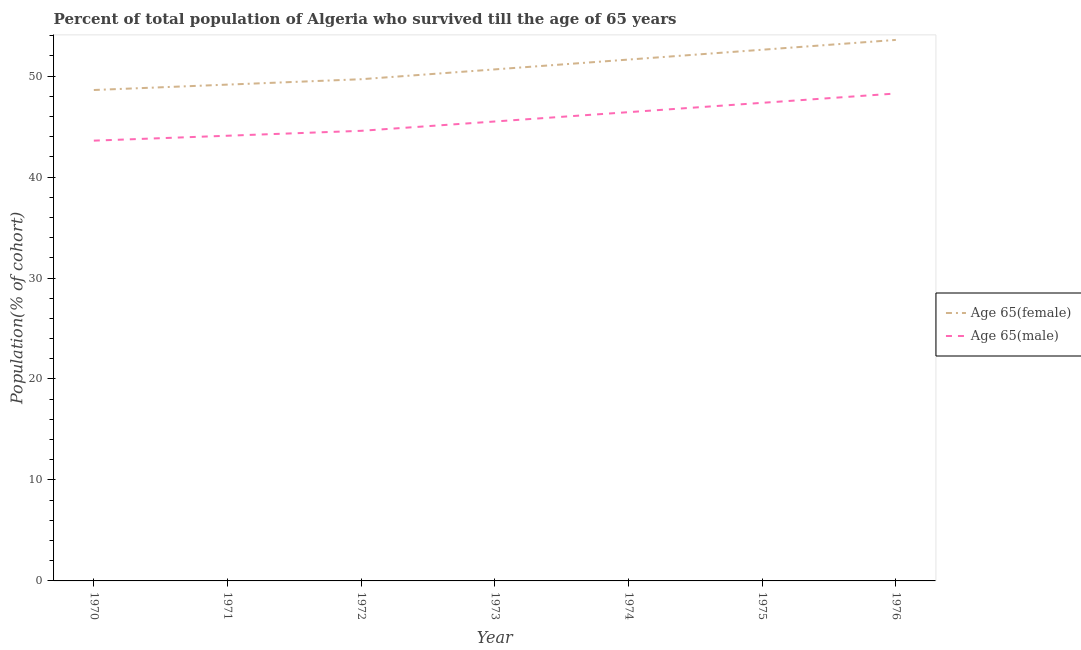Does the line corresponding to percentage of male population who survived till age of 65 intersect with the line corresponding to percentage of female population who survived till age of 65?
Ensure brevity in your answer.  No. Is the number of lines equal to the number of legend labels?
Keep it short and to the point. Yes. What is the percentage of female population who survived till age of 65 in 1976?
Offer a very short reply. 53.58. Across all years, what is the maximum percentage of male population who survived till age of 65?
Your answer should be very brief. 48.27. Across all years, what is the minimum percentage of male population who survived till age of 65?
Ensure brevity in your answer.  43.6. In which year was the percentage of male population who survived till age of 65 maximum?
Make the answer very short. 1976. In which year was the percentage of male population who survived till age of 65 minimum?
Make the answer very short. 1970. What is the total percentage of female population who survived till age of 65 in the graph?
Your response must be concise. 355.94. What is the difference between the percentage of male population who survived till age of 65 in 1970 and that in 1973?
Your answer should be compact. -1.9. What is the difference between the percentage of female population who survived till age of 65 in 1972 and the percentage of male population who survived till age of 65 in 1970?
Give a very brief answer. 6.08. What is the average percentage of male population who survived till age of 65 per year?
Your response must be concise. 45.69. In the year 1975, what is the difference between the percentage of male population who survived till age of 65 and percentage of female population who survived till age of 65?
Provide a short and direct response. -5.26. What is the ratio of the percentage of female population who survived till age of 65 in 1974 to that in 1976?
Keep it short and to the point. 0.96. Is the percentage of female population who survived till age of 65 in 1973 less than that in 1976?
Ensure brevity in your answer.  Yes. What is the difference between the highest and the second highest percentage of male population who survived till age of 65?
Your answer should be very brief. 0.92. What is the difference between the highest and the lowest percentage of male population who survived till age of 65?
Your answer should be very brief. 4.67. In how many years, is the percentage of male population who survived till age of 65 greater than the average percentage of male population who survived till age of 65 taken over all years?
Your response must be concise. 3. Is the sum of the percentage of male population who survived till age of 65 in 1975 and 1976 greater than the maximum percentage of female population who survived till age of 65 across all years?
Offer a terse response. Yes. Does the percentage of male population who survived till age of 65 monotonically increase over the years?
Your response must be concise. Yes. How many lines are there?
Give a very brief answer. 2. What is the difference between two consecutive major ticks on the Y-axis?
Ensure brevity in your answer.  10. Are the values on the major ticks of Y-axis written in scientific E-notation?
Provide a short and direct response. No. How many legend labels are there?
Your answer should be compact. 2. What is the title of the graph?
Your response must be concise. Percent of total population of Algeria who survived till the age of 65 years. Does "Number of arrivals" appear as one of the legend labels in the graph?
Provide a succinct answer. No. What is the label or title of the Y-axis?
Offer a terse response. Population(% of cohort). What is the Population(% of cohort) of Age 65(female) in 1970?
Make the answer very short. 48.62. What is the Population(% of cohort) of Age 65(male) in 1970?
Keep it short and to the point. 43.6. What is the Population(% of cohort) in Age 65(female) in 1971?
Ensure brevity in your answer.  49.15. What is the Population(% of cohort) in Age 65(male) in 1971?
Make the answer very short. 44.09. What is the Population(% of cohort) of Age 65(female) in 1972?
Make the answer very short. 49.69. What is the Population(% of cohort) in Age 65(male) in 1972?
Keep it short and to the point. 44.58. What is the Population(% of cohort) of Age 65(female) in 1973?
Make the answer very short. 50.66. What is the Population(% of cohort) of Age 65(male) in 1973?
Your response must be concise. 45.5. What is the Population(% of cohort) of Age 65(female) in 1974?
Your answer should be very brief. 51.63. What is the Population(% of cohort) in Age 65(male) in 1974?
Provide a succinct answer. 46.42. What is the Population(% of cohort) of Age 65(female) in 1975?
Provide a short and direct response. 52.61. What is the Population(% of cohort) of Age 65(male) in 1975?
Your answer should be very brief. 47.35. What is the Population(% of cohort) of Age 65(female) in 1976?
Offer a very short reply. 53.58. What is the Population(% of cohort) in Age 65(male) in 1976?
Provide a succinct answer. 48.27. Across all years, what is the maximum Population(% of cohort) of Age 65(female)?
Offer a very short reply. 53.58. Across all years, what is the maximum Population(% of cohort) of Age 65(male)?
Your response must be concise. 48.27. Across all years, what is the minimum Population(% of cohort) of Age 65(female)?
Give a very brief answer. 48.62. Across all years, what is the minimum Population(% of cohort) in Age 65(male)?
Your answer should be compact. 43.6. What is the total Population(% of cohort) of Age 65(female) in the graph?
Your response must be concise. 355.94. What is the total Population(% of cohort) in Age 65(male) in the graph?
Provide a succinct answer. 319.82. What is the difference between the Population(% of cohort) of Age 65(female) in 1970 and that in 1971?
Keep it short and to the point. -0.53. What is the difference between the Population(% of cohort) in Age 65(male) in 1970 and that in 1971?
Give a very brief answer. -0.49. What is the difference between the Population(% of cohort) in Age 65(female) in 1970 and that in 1972?
Make the answer very short. -1.07. What is the difference between the Population(% of cohort) in Age 65(male) in 1970 and that in 1972?
Your answer should be compact. -0.97. What is the difference between the Population(% of cohort) in Age 65(female) in 1970 and that in 1973?
Make the answer very short. -2.04. What is the difference between the Population(% of cohort) of Age 65(male) in 1970 and that in 1973?
Offer a very short reply. -1.9. What is the difference between the Population(% of cohort) in Age 65(female) in 1970 and that in 1974?
Offer a very short reply. -3.02. What is the difference between the Population(% of cohort) of Age 65(male) in 1970 and that in 1974?
Your answer should be compact. -2.82. What is the difference between the Population(% of cohort) in Age 65(female) in 1970 and that in 1975?
Your answer should be very brief. -3.99. What is the difference between the Population(% of cohort) in Age 65(male) in 1970 and that in 1975?
Your answer should be very brief. -3.75. What is the difference between the Population(% of cohort) in Age 65(female) in 1970 and that in 1976?
Ensure brevity in your answer.  -4.96. What is the difference between the Population(% of cohort) in Age 65(male) in 1970 and that in 1976?
Provide a short and direct response. -4.67. What is the difference between the Population(% of cohort) of Age 65(female) in 1971 and that in 1972?
Make the answer very short. -0.53. What is the difference between the Population(% of cohort) in Age 65(male) in 1971 and that in 1972?
Your answer should be compact. -0.49. What is the difference between the Population(% of cohort) in Age 65(female) in 1971 and that in 1973?
Offer a terse response. -1.51. What is the difference between the Population(% of cohort) of Age 65(male) in 1971 and that in 1973?
Your response must be concise. -1.41. What is the difference between the Population(% of cohort) of Age 65(female) in 1971 and that in 1974?
Ensure brevity in your answer.  -2.48. What is the difference between the Population(% of cohort) of Age 65(male) in 1971 and that in 1974?
Your response must be concise. -2.33. What is the difference between the Population(% of cohort) of Age 65(female) in 1971 and that in 1975?
Offer a very short reply. -3.45. What is the difference between the Population(% of cohort) of Age 65(male) in 1971 and that in 1975?
Your answer should be compact. -3.26. What is the difference between the Population(% of cohort) in Age 65(female) in 1971 and that in 1976?
Offer a very short reply. -4.43. What is the difference between the Population(% of cohort) in Age 65(male) in 1971 and that in 1976?
Provide a succinct answer. -4.18. What is the difference between the Population(% of cohort) in Age 65(female) in 1972 and that in 1973?
Keep it short and to the point. -0.97. What is the difference between the Population(% of cohort) in Age 65(male) in 1972 and that in 1973?
Your answer should be very brief. -0.92. What is the difference between the Population(% of cohort) in Age 65(female) in 1972 and that in 1974?
Offer a terse response. -1.95. What is the difference between the Population(% of cohort) in Age 65(male) in 1972 and that in 1974?
Your answer should be very brief. -1.85. What is the difference between the Population(% of cohort) in Age 65(female) in 1972 and that in 1975?
Ensure brevity in your answer.  -2.92. What is the difference between the Population(% of cohort) of Age 65(male) in 1972 and that in 1975?
Your answer should be very brief. -2.77. What is the difference between the Population(% of cohort) of Age 65(female) in 1972 and that in 1976?
Make the answer very short. -3.89. What is the difference between the Population(% of cohort) of Age 65(male) in 1972 and that in 1976?
Your answer should be compact. -3.7. What is the difference between the Population(% of cohort) of Age 65(female) in 1973 and that in 1974?
Your answer should be very brief. -0.97. What is the difference between the Population(% of cohort) of Age 65(male) in 1973 and that in 1974?
Your response must be concise. -0.92. What is the difference between the Population(% of cohort) of Age 65(female) in 1973 and that in 1975?
Your response must be concise. -1.95. What is the difference between the Population(% of cohort) of Age 65(male) in 1973 and that in 1975?
Your answer should be very brief. -1.85. What is the difference between the Population(% of cohort) in Age 65(female) in 1973 and that in 1976?
Your answer should be very brief. -2.92. What is the difference between the Population(% of cohort) in Age 65(male) in 1973 and that in 1976?
Your response must be concise. -2.77. What is the difference between the Population(% of cohort) in Age 65(female) in 1974 and that in 1975?
Your answer should be very brief. -0.97. What is the difference between the Population(% of cohort) in Age 65(male) in 1974 and that in 1975?
Your answer should be compact. -0.92. What is the difference between the Population(% of cohort) in Age 65(female) in 1974 and that in 1976?
Provide a succinct answer. -1.95. What is the difference between the Population(% of cohort) of Age 65(male) in 1974 and that in 1976?
Make the answer very short. -1.85. What is the difference between the Population(% of cohort) of Age 65(female) in 1975 and that in 1976?
Ensure brevity in your answer.  -0.97. What is the difference between the Population(% of cohort) of Age 65(male) in 1975 and that in 1976?
Provide a succinct answer. -0.92. What is the difference between the Population(% of cohort) in Age 65(female) in 1970 and the Population(% of cohort) in Age 65(male) in 1971?
Provide a short and direct response. 4.53. What is the difference between the Population(% of cohort) of Age 65(female) in 1970 and the Population(% of cohort) of Age 65(male) in 1972?
Offer a terse response. 4.04. What is the difference between the Population(% of cohort) in Age 65(female) in 1970 and the Population(% of cohort) in Age 65(male) in 1973?
Provide a short and direct response. 3.12. What is the difference between the Population(% of cohort) of Age 65(female) in 1970 and the Population(% of cohort) of Age 65(male) in 1974?
Offer a very short reply. 2.19. What is the difference between the Population(% of cohort) in Age 65(female) in 1970 and the Population(% of cohort) in Age 65(male) in 1975?
Your response must be concise. 1.27. What is the difference between the Population(% of cohort) of Age 65(female) in 1970 and the Population(% of cohort) of Age 65(male) in 1976?
Your response must be concise. 0.35. What is the difference between the Population(% of cohort) of Age 65(female) in 1971 and the Population(% of cohort) of Age 65(male) in 1972?
Make the answer very short. 4.58. What is the difference between the Population(% of cohort) in Age 65(female) in 1971 and the Population(% of cohort) in Age 65(male) in 1973?
Offer a terse response. 3.65. What is the difference between the Population(% of cohort) of Age 65(female) in 1971 and the Population(% of cohort) of Age 65(male) in 1974?
Give a very brief answer. 2.73. What is the difference between the Population(% of cohort) of Age 65(female) in 1971 and the Population(% of cohort) of Age 65(male) in 1975?
Make the answer very short. 1.8. What is the difference between the Population(% of cohort) in Age 65(female) in 1971 and the Population(% of cohort) in Age 65(male) in 1976?
Provide a short and direct response. 0.88. What is the difference between the Population(% of cohort) of Age 65(female) in 1972 and the Population(% of cohort) of Age 65(male) in 1973?
Keep it short and to the point. 4.19. What is the difference between the Population(% of cohort) of Age 65(female) in 1972 and the Population(% of cohort) of Age 65(male) in 1974?
Offer a very short reply. 3.26. What is the difference between the Population(% of cohort) of Age 65(female) in 1972 and the Population(% of cohort) of Age 65(male) in 1975?
Provide a short and direct response. 2.34. What is the difference between the Population(% of cohort) of Age 65(female) in 1972 and the Population(% of cohort) of Age 65(male) in 1976?
Give a very brief answer. 1.41. What is the difference between the Population(% of cohort) of Age 65(female) in 1973 and the Population(% of cohort) of Age 65(male) in 1974?
Offer a very short reply. 4.24. What is the difference between the Population(% of cohort) of Age 65(female) in 1973 and the Population(% of cohort) of Age 65(male) in 1975?
Make the answer very short. 3.31. What is the difference between the Population(% of cohort) of Age 65(female) in 1973 and the Population(% of cohort) of Age 65(male) in 1976?
Make the answer very short. 2.39. What is the difference between the Population(% of cohort) of Age 65(female) in 1974 and the Population(% of cohort) of Age 65(male) in 1975?
Provide a succinct answer. 4.28. What is the difference between the Population(% of cohort) of Age 65(female) in 1974 and the Population(% of cohort) of Age 65(male) in 1976?
Provide a succinct answer. 3.36. What is the difference between the Population(% of cohort) of Age 65(female) in 1975 and the Population(% of cohort) of Age 65(male) in 1976?
Provide a succinct answer. 4.33. What is the average Population(% of cohort) in Age 65(female) per year?
Give a very brief answer. 50.85. What is the average Population(% of cohort) in Age 65(male) per year?
Ensure brevity in your answer.  45.69. In the year 1970, what is the difference between the Population(% of cohort) in Age 65(female) and Population(% of cohort) in Age 65(male)?
Provide a short and direct response. 5.01. In the year 1971, what is the difference between the Population(% of cohort) in Age 65(female) and Population(% of cohort) in Age 65(male)?
Offer a terse response. 5.06. In the year 1972, what is the difference between the Population(% of cohort) in Age 65(female) and Population(% of cohort) in Age 65(male)?
Offer a terse response. 5.11. In the year 1973, what is the difference between the Population(% of cohort) in Age 65(female) and Population(% of cohort) in Age 65(male)?
Offer a terse response. 5.16. In the year 1974, what is the difference between the Population(% of cohort) of Age 65(female) and Population(% of cohort) of Age 65(male)?
Offer a very short reply. 5.21. In the year 1975, what is the difference between the Population(% of cohort) of Age 65(female) and Population(% of cohort) of Age 65(male)?
Give a very brief answer. 5.26. In the year 1976, what is the difference between the Population(% of cohort) of Age 65(female) and Population(% of cohort) of Age 65(male)?
Your answer should be very brief. 5.31. What is the ratio of the Population(% of cohort) of Age 65(female) in 1970 to that in 1971?
Your answer should be compact. 0.99. What is the ratio of the Population(% of cohort) in Age 65(female) in 1970 to that in 1972?
Your response must be concise. 0.98. What is the ratio of the Population(% of cohort) of Age 65(male) in 1970 to that in 1972?
Make the answer very short. 0.98. What is the ratio of the Population(% of cohort) of Age 65(female) in 1970 to that in 1973?
Keep it short and to the point. 0.96. What is the ratio of the Population(% of cohort) in Age 65(female) in 1970 to that in 1974?
Offer a terse response. 0.94. What is the ratio of the Population(% of cohort) of Age 65(male) in 1970 to that in 1974?
Ensure brevity in your answer.  0.94. What is the ratio of the Population(% of cohort) in Age 65(female) in 1970 to that in 1975?
Keep it short and to the point. 0.92. What is the ratio of the Population(% of cohort) in Age 65(male) in 1970 to that in 1975?
Your response must be concise. 0.92. What is the ratio of the Population(% of cohort) in Age 65(female) in 1970 to that in 1976?
Your response must be concise. 0.91. What is the ratio of the Population(% of cohort) of Age 65(male) in 1970 to that in 1976?
Your answer should be very brief. 0.9. What is the ratio of the Population(% of cohort) of Age 65(female) in 1971 to that in 1972?
Provide a succinct answer. 0.99. What is the ratio of the Population(% of cohort) of Age 65(male) in 1971 to that in 1972?
Offer a very short reply. 0.99. What is the ratio of the Population(% of cohort) in Age 65(female) in 1971 to that in 1973?
Offer a terse response. 0.97. What is the ratio of the Population(% of cohort) in Age 65(male) in 1971 to that in 1973?
Ensure brevity in your answer.  0.97. What is the ratio of the Population(% of cohort) of Age 65(male) in 1971 to that in 1974?
Give a very brief answer. 0.95. What is the ratio of the Population(% of cohort) of Age 65(female) in 1971 to that in 1975?
Provide a succinct answer. 0.93. What is the ratio of the Population(% of cohort) in Age 65(male) in 1971 to that in 1975?
Your answer should be very brief. 0.93. What is the ratio of the Population(% of cohort) of Age 65(female) in 1971 to that in 1976?
Ensure brevity in your answer.  0.92. What is the ratio of the Population(% of cohort) in Age 65(male) in 1971 to that in 1976?
Your response must be concise. 0.91. What is the ratio of the Population(% of cohort) in Age 65(female) in 1972 to that in 1973?
Ensure brevity in your answer.  0.98. What is the ratio of the Population(% of cohort) in Age 65(male) in 1972 to that in 1973?
Provide a succinct answer. 0.98. What is the ratio of the Population(% of cohort) in Age 65(female) in 1972 to that in 1974?
Your answer should be compact. 0.96. What is the ratio of the Population(% of cohort) of Age 65(male) in 1972 to that in 1974?
Your response must be concise. 0.96. What is the ratio of the Population(% of cohort) of Age 65(female) in 1972 to that in 1975?
Your answer should be compact. 0.94. What is the ratio of the Population(% of cohort) of Age 65(male) in 1972 to that in 1975?
Provide a succinct answer. 0.94. What is the ratio of the Population(% of cohort) of Age 65(female) in 1972 to that in 1976?
Make the answer very short. 0.93. What is the ratio of the Population(% of cohort) of Age 65(male) in 1972 to that in 1976?
Your answer should be very brief. 0.92. What is the ratio of the Population(% of cohort) in Age 65(female) in 1973 to that in 1974?
Your answer should be very brief. 0.98. What is the ratio of the Population(% of cohort) of Age 65(male) in 1973 to that in 1974?
Provide a short and direct response. 0.98. What is the ratio of the Population(% of cohort) in Age 65(male) in 1973 to that in 1975?
Make the answer very short. 0.96. What is the ratio of the Population(% of cohort) in Age 65(female) in 1973 to that in 1976?
Offer a terse response. 0.95. What is the ratio of the Population(% of cohort) of Age 65(male) in 1973 to that in 1976?
Ensure brevity in your answer.  0.94. What is the ratio of the Population(% of cohort) in Age 65(female) in 1974 to that in 1975?
Keep it short and to the point. 0.98. What is the ratio of the Population(% of cohort) in Age 65(male) in 1974 to that in 1975?
Your answer should be very brief. 0.98. What is the ratio of the Population(% of cohort) of Age 65(female) in 1974 to that in 1976?
Make the answer very short. 0.96. What is the ratio of the Population(% of cohort) of Age 65(male) in 1974 to that in 1976?
Make the answer very short. 0.96. What is the ratio of the Population(% of cohort) of Age 65(female) in 1975 to that in 1976?
Offer a terse response. 0.98. What is the ratio of the Population(% of cohort) in Age 65(male) in 1975 to that in 1976?
Offer a very short reply. 0.98. What is the difference between the highest and the second highest Population(% of cohort) of Age 65(female)?
Offer a terse response. 0.97. What is the difference between the highest and the second highest Population(% of cohort) of Age 65(male)?
Keep it short and to the point. 0.92. What is the difference between the highest and the lowest Population(% of cohort) in Age 65(female)?
Give a very brief answer. 4.96. What is the difference between the highest and the lowest Population(% of cohort) of Age 65(male)?
Offer a terse response. 4.67. 